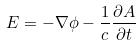<formula> <loc_0><loc_0><loc_500><loc_500>E = - \nabla \phi - \frac { 1 } { c } \frac { \partial A } { \partial t }</formula> 